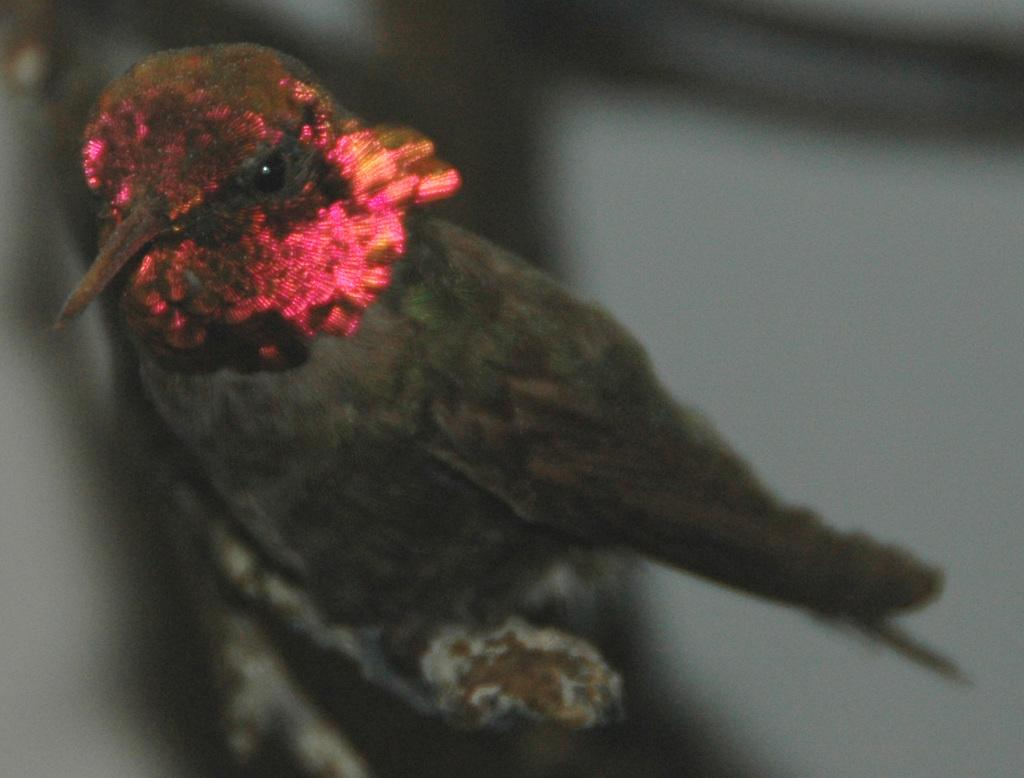What type of animal is in the image? There is a bird in the image. Where is the bird located? The bird is on a stem. Can you describe the quality of the image? The image is blurred. What type of dress is the bird wearing in the image? There is no dress present in the image, as the subject is a bird. Can you see a truck in the image? There is no truck present in the image. 